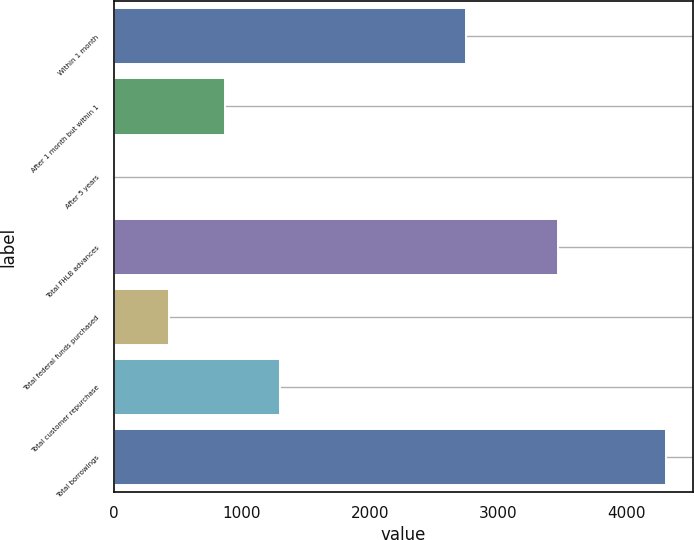Convert chart to OTSL. <chart><loc_0><loc_0><loc_500><loc_500><bar_chart><fcel>Within 1 month<fcel>After 1 month but within 1<fcel>After 5 years<fcel>Total FHLB advances<fcel>Total federal funds purchased<fcel>Total customer repurchase<fcel>Total borrowings<nl><fcel>2750<fcel>865.62<fcel>5.2<fcel>3463.8<fcel>435.41<fcel>1295.83<fcel>4307.3<nl></chart> 